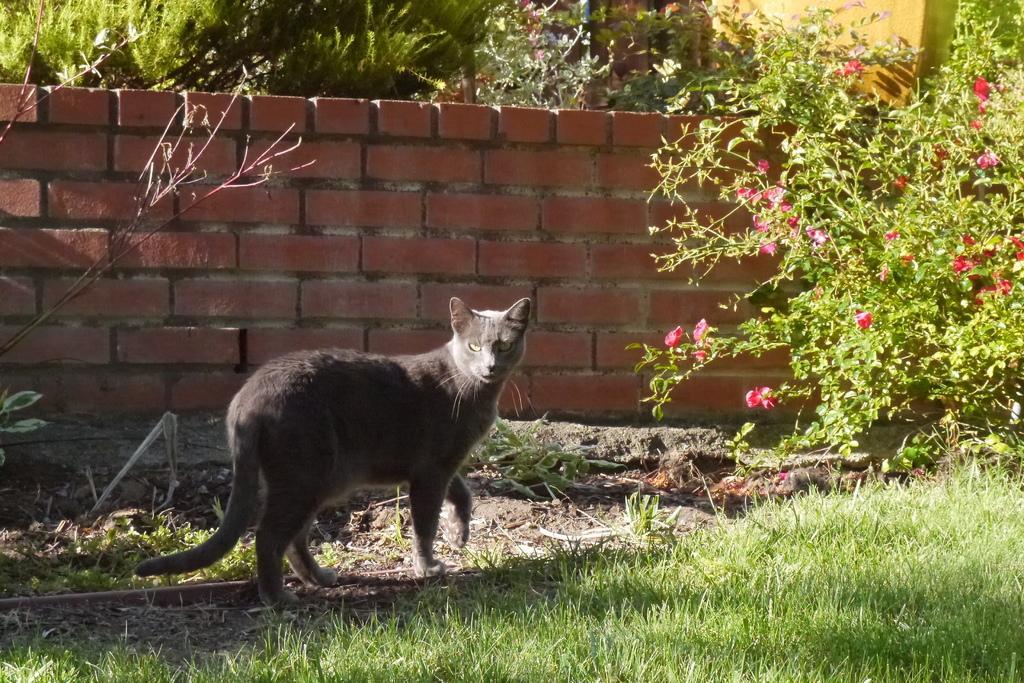How would you summarize this image in a sentence or two? In the center of the image an animal is there. In the background of the image we can see wall, some plants, flowers. At the bottom of the image we can see some grass. 